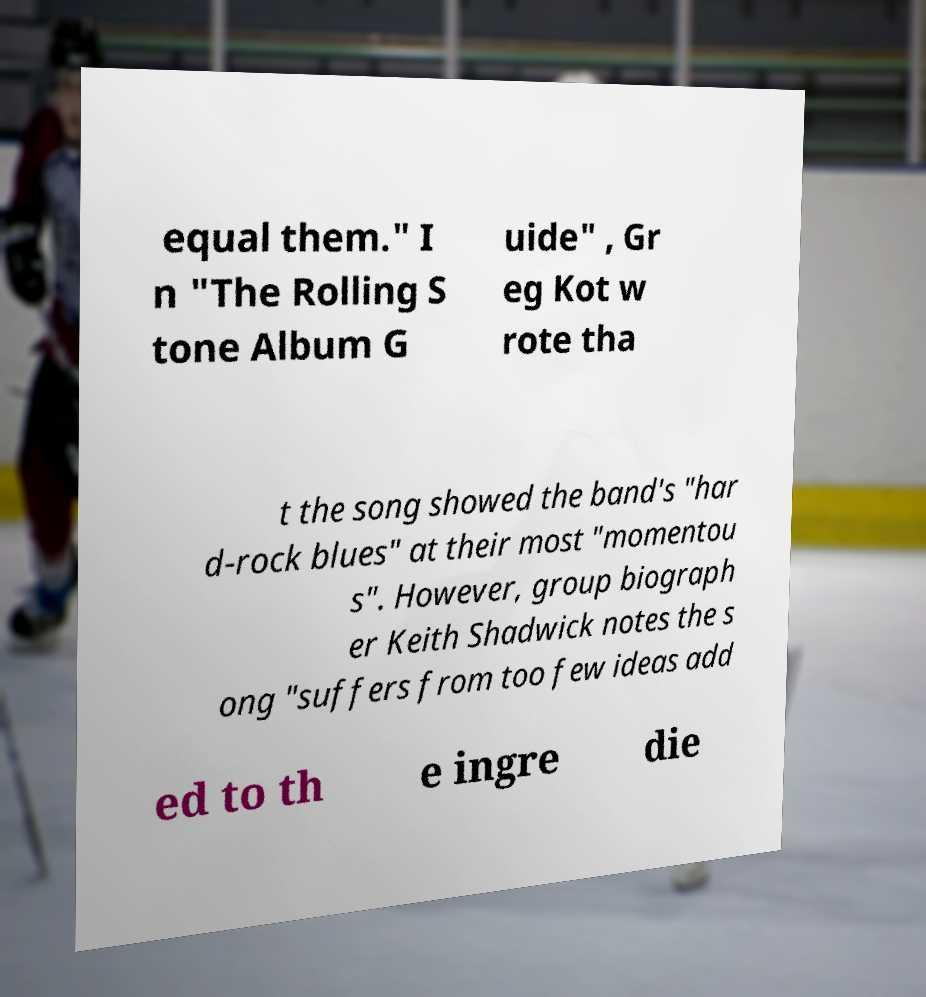Could you assist in decoding the text presented in this image and type it out clearly? equal them." I n "The Rolling S tone Album G uide" , Gr eg Kot w rote tha t the song showed the band's "har d-rock blues" at their most "momentou s". However, group biograph er Keith Shadwick notes the s ong "suffers from too few ideas add ed to th e ingre die 